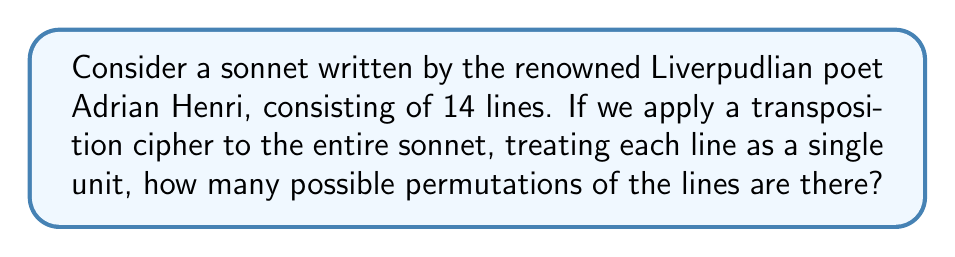Can you answer this question? To solve this problem, we need to understand the following concepts:

1. A sonnet typically consists of 14 lines.
2. A transposition cipher rearranges the order of elements (in this case, lines) without changing their content.
3. The number of possible permutations for a set of distinct elements is given by the factorial of the number of elements.

Let's proceed step-by-step:

1. We have 14 distinct lines in the sonnet.
2. Each line can be placed in any position, and the order matters.
3. The number of permutations is therefore 14!

To calculate 14!:

$$14! = 14 \times 13 \times 12 \times 11 \times 10 \times 9 \times 8 \times 7 \times 6 \times 5 \times 4 \times 3 \times 2 \times 1$$

This can be computed as:

$$14! = 87,178,291,200$$

Therefore, there are 87,178,291,200 possible permutations of the lines in Adrian Henri's sonnet when applying a transposition cipher.
Answer: $87,178,291,200$ 